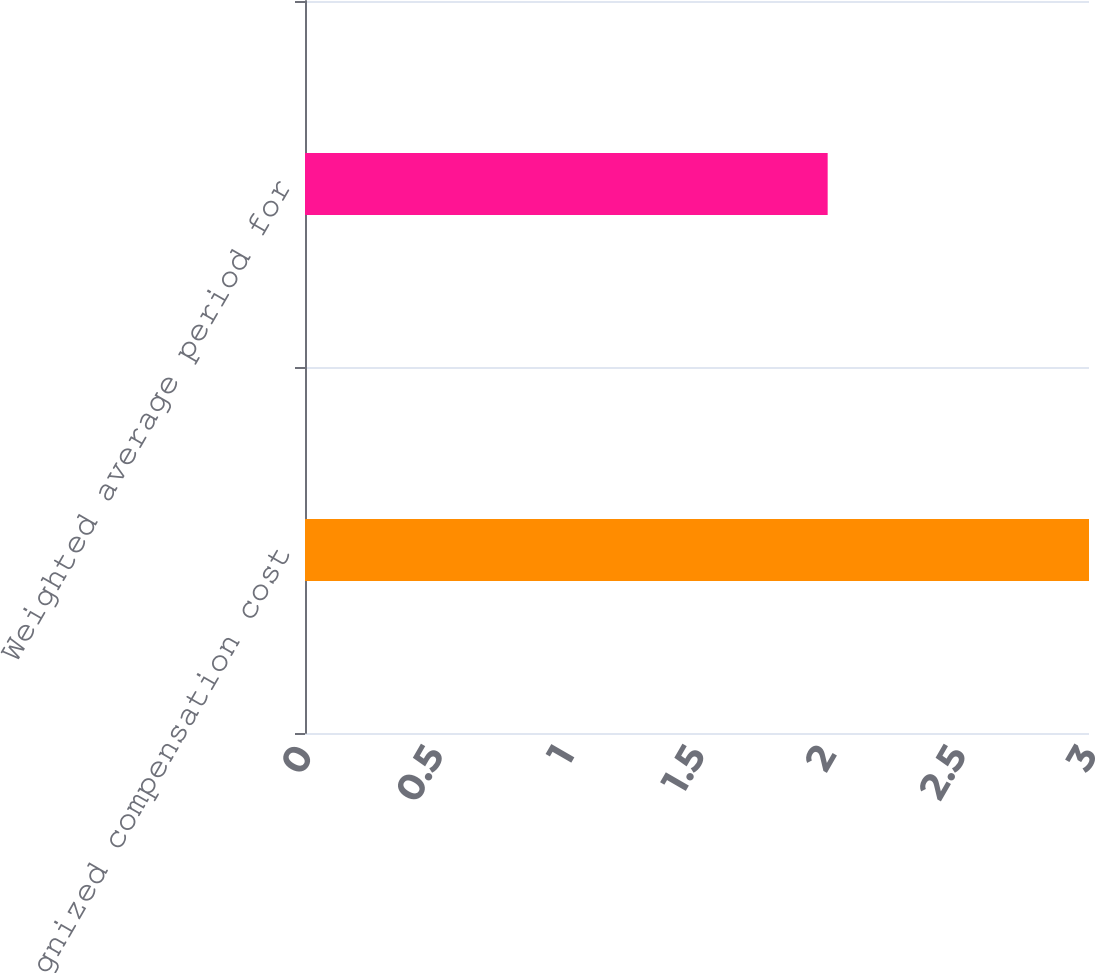Convert chart. <chart><loc_0><loc_0><loc_500><loc_500><bar_chart><fcel>Unrecognized compensation cost<fcel>Weighted average period for<nl><fcel>3<fcel>2<nl></chart> 